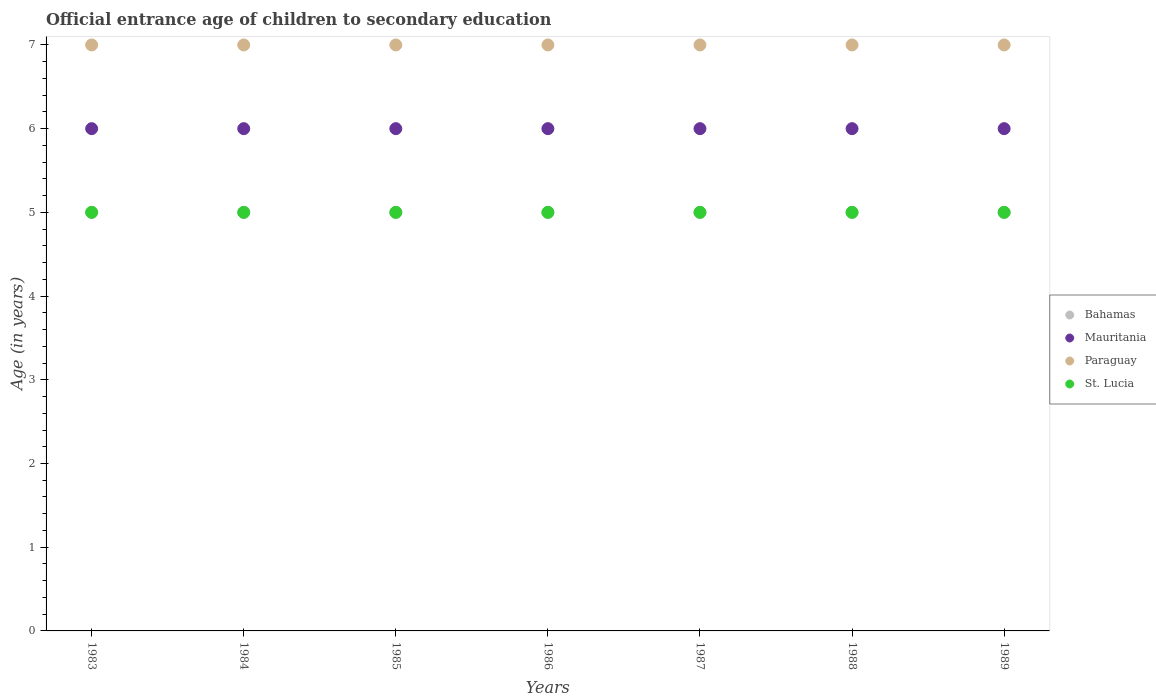How many different coloured dotlines are there?
Your answer should be compact. 4. What is the secondary school starting age of children in Mauritania in 1988?
Give a very brief answer. 6. Across all years, what is the maximum secondary school starting age of children in St. Lucia?
Offer a very short reply. 5. Across all years, what is the minimum secondary school starting age of children in St. Lucia?
Offer a terse response. 5. In which year was the secondary school starting age of children in St. Lucia minimum?
Your answer should be compact. 1983. What is the total secondary school starting age of children in Mauritania in the graph?
Give a very brief answer. 42. What is the difference between the secondary school starting age of children in Bahamas in 1986 and the secondary school starting age of children in Paraguay in 1987?
Provide a short and direct response. -2. In the year 1983, what is the difference between the secondary school starting age of children in St. Lucia and secondary school starting age of children in Mauritania?
Offer a very short reply. -1. Is the difference between the secondary school starting age of children in St. Lucia in 1988 and 1989 greater than the difference between the secondary school starting age of children in Mauritania in 1988 and 1989?
Your answer should be compact. No. What is the difference between the highest and the lowest secondary school starting age of children in Bahamas?
Your answer should be compact. 0. Is the secondary school starting age of children in Mauritania strictly less than the secondary school starting age of children in Paraguay over the years?
Provide a succinct answer. Yes. How many dotlines are there?
Offer a very short reply. 4. How many years are there in the graph?
Ensure brevity in your answer.  7. Are the values on the major ticks of Y-axis written in scientific E-notation?
Offer a terse response. No. Where does the legend appear in the graph?
Make the answer very short. Center right. How are the legend labels stacked?
Ensure brevity in your answer.  Vertical. What is the title of the graph?
Give a very brief answer. Official entrance age of children to secondary education. What is the label or title of the Y-axis?
Offer a very short reply. Age (in years). What is the Age (in years) of Mauritania in 1983?
Your answer should be very brief. 6. What is the Age (in years) in Bahamas in 1984?
Make the answer very short. 5. What is the Age (in years) in Paraguay in 1984?
Offer a terse response. 7. What is the Age (in years) in Paraguay in 1985?
Keep it short and to the point. 7. What is the Age (in years) in Mauritania in 1986?
Offer a very short reply. 6. What is the Age (in years) in Paraguay in 1986?
Give a very brief answer. 7. What is the Age (in years) in Bahamas in 1987?
Give a very brief answer. 5. What is the Age (in years) of Mauritania in 1988?
Offer a very short reply. 6. What is the Age (in years) in Paraguay in 1988?
Your answer should be compact. 7. What is the Age (in years) of St. Lucia in 1988?
Provide a succinct answer. 5. What is the Age (in years) of Bahamas in 1989?
Your answer should be compact. 5. What is the Age (in years) of Paraguay in 1989?
Ensure brevity in your answer.  7. Across all years, what is the maximum Age (in years) of Bahamas?
Offer a very short reply. 5. Across all years, what is the maximum Age (in years) of Mauritania?
Your answer should be compact. 6. Across all years, what is the maximum Age (in years) of Paraguay?
Provide a succinct answer. 7. Across all years, what is the minimum Age (in years) in Paraguay?
Make the answer very short. 7. Across all years, what is the minimum Age (in years) in St. Lucia?
Offer a terse response. 5. What is the total Age (in years) in St. Lucia in the graph?
Your answer should be very brief. 35. What is the difference between the Age (in years) of Mauritania in 1983 and that in 1984?
Your answer should be very brief. 0. What is the difference between the Age (in years) in Mauritania in 1983 and that in 1985?
Make the answer very short. 0. What is the difference between the Age (in years) of Paraguay in 1983 and that in 1985?
Provide a short and direct response. 0. What is the difference between the Age (in years) in Bahamas in 1983 and that in 1986?
Provide a succinct answer. 0. What is the difference between the Age (in years) of Paraguay in 1983 and that in 1986?
Keep it short and to the point. 0. What is the difference between the Age (in years) in Bahamas in 1983 and that in 1987?
Your response must be concise. 0. What is the difference between the Age (in years) of Paraguay in 1983 and that in 1987?
Your response must be concise. 0. What is the difference between the Age (in years) in St. Lucia in 1983 and that in 1987?
Offer a very short reply. 0. What is the difference between the Age (in years) of Mauritania in 1983 and that in 1988?
Your answer should be very brief. 0. What is the difference between the Age (in years) of Bahamas in 1983 and that in 1989?
Provide a succinct answer. 0. What is the difference between the Age (in years) in Mauritania in 1984 and that in 1985?
Offer a terse response. 0. What is the difference between the Age (in years) in Mauritania in 1984 and that in 1986?
Your answer should be compact. 0. What is the difference between the Age (in years) in Paraguay in 1984 and that in 1986?
Make the answer very short. 0. What is the difference between the Age (in years) of Bahamas in 1984 and that in 1987?
Your response must be concise. 0. What is the difference between the Age (in years) of Paraguay in 1984 and that in 1987?
Keep it short and to the point. 0. What is the difference between the Age (in years) of Bahamas in 1984 and that in 1988?
Keep it short and to the point. 0. What is the difference between the Age (in years) of Bahamas in 1984 and that in 1989?
Give a very brief answer. 0. What is the difference between the Age (in years) in Mauritania in 1984 and that in 1989?
Offer a terse response. 0. What is the difference between the Age (in years) of Paraguay in 1984 and that in 1989?
Keep it short and to the point. 0. What is the difference between the Age (in years) of St. Lucia in 1984 and that in 1989?
Provide a short and direct response. 0. What is the difference between the Age (in years) of Bahamas in 1985 and that in 1986?
Ensure brevity in your answer.  0. What is the difference between the Age (in years) in Paraguay in 1985 and that in 1986?
Your response must be concise. 0. What is the difference between the Age (in years) of St. Lucia in 1985 and that in 1986?
Offer a very short reply. 0. What is the difference between the Age (in years) in Bahamas in 1985 and that in 1987?
Provide a short and direct response. 0. What is the difference between the Age (in years) of Mauritania in 1985 and that in 1987?
Provide a succinct answer. 0. What is the difference between the Age (in years) of Mauritania in 1985 and that in 1988?
Ensure brevity in your answer.  0. What is the difference between the Age (in years) in St. Lucia in 1985 and that in 1989?
Provide a short and direct response. 0. What is the difference between the Age (in years) in Bahamas in 1986 and that in 1987?
Provide a succinct answer. 0. What is the difference between the Age (in years) of Mauritania in 1986 and that in 1987?
Make the answer very short. 0. What is the difference between the Age (in years) in Paraguay in 1986 and that in 1987?
Provide a succinct answer. 0. What is the difference between the Age (in years) in Paraguay in 1986 and that in 1988?
Your answer should be compact. 0. What is the difference between the Age (in years) of St. Lucia in 1986 and that in 1988?
Make the answer very short. 0. What is the difference between the Age (in years) of Paraguay in 1986 and that in 1989?
Give a very brief answer. 0. What is the difference between the Age (in years) in St. Lucia in 1986 and that in 1989?
Your answer should be very brief. 0. What is the difference between the Age (in years) of Bahamas in 1987 and that in 1988?
Your answer should be compact. 0. What is the difference between the Age (in years) of St. Lucia in 1987 and that in 1988?
Your answer should be compact. 0. What is the difference between the Age (in years) in Bahamas in 1987 and that in 1989?
Make the answer very short. 0. What is the difference between the Age (in years) of Mauritania in 1987 and that in 1989?
Ensure brevity in your answer.  0. What is the difference between the Age (in years) in St. Lucia in 1987 and that in 1989?
Your answer should be compact. 0. What is the difference between the Age (in years) of Bahamas in 1988 and that in 1989?
Your answer should be compact. 0. What is the difference between the Age (in years) of Paraguay in 1988 and that in 1989?
Offer a terse response. 0. What is the difference between the Age (in years) in Bahamas in 1983 and the Age (in years) in St. Lucia in 1984?
Your answer should be very brief. 0. What is the difference between the Age (in years) in Bahamas in 1983 and the Age (in years) in St. Lucia in 1986?
Make the answer very short. 0. What is the difference between the Age (in years) of Paraguay in 1983 and the Age (in years) of St. Lucia in 1986?
Give a very brief answer. 2. What is the difference between the Age (in years) of Bahamas in 1983 and the Age (in years) of Mauritania in 1987?
Give a very brief answer. -1. What is the difference between the Age (in years) in Bahamas in 1983 and the Age (in years) in St. Lucia in 1988?
Your answer should be very brief. 0. What is the difference between the Age (in years) in Mauritania in 1983 and the Age (in years) in Paraguay in 1988?
Offer a very short reply. -1. What is the difference between the Age (in years) of Paraguay in 1983 and the Age (in years) of St. Lucia in 1988?
Ensure brevity in your answer.  2. What is the difference between the Age (in years) in Bahamas in 1983 and the Age (in years) in Mauritania in 1989?
Provide a succinct answer. -1. What is the difference between the Age (in years) in Bahamas in 1983 and the Age (in years) in St. Lucia in 1989?
Keep it short and to the point. 0. What is the difference between the Age (in years) in Mauritania in 1983 and the Age (in years) in Paraguay in 1989?
Make the answer very short. -1. What is the difference between the Age (in years) in Mauritania in 1983 and the Age (in years) in St. Lucia in 1989?
Provide a short and direct response. 1. What is the difference between the Age (in years) in Bahamas in 1984 and the Age (in years) in Paraguay in 1985?
Keep it short and to the point. -2. What is the difference between the Age (in years) in Bahamas in 1984 and the Age (in years) in St. Lucia in 1985?
Your response must be concise. 0. What is the difference between the Age (in years) in Mauritania in 1984 and the Age (in years) in Paraguay in 1985?
Your answer should be very brief. -1. What is the difference between the Age (in years) in Mauritania in 1984 and the Age (in years) in St. Lucia in 1985?
Your answer should be very brief. 1. What is the difference between the Age (in years) in Bahamas in 1984 and the Age (in years) in Mauritania in 1986?
Your response must be concise. -1. What is the difference between the Age (in years) of Paraguay in 1984 and the Age (in years) of St. Lucia in 1986?
Offer a terse response. 2. What is the difference between the Age (in years) of Bahamas in 1984 and the Age (in years) of Mauritania in 1987?
Your answer should be compact. -1. What is the difference between the Age (in years) in Mauritania in 1984 and the Age (in years) in Paraguay in 1987?
Keep it short and to the point. -1. What is the difference between the Age (in years) in Mauritania in 1984 and the Age (in years) in St. Lucia in 1987?
Your answer should be very brief. 1. What is the difference between the Age (in years) in Paraguay in 1984 and the Age (in years) in St. Lucia in 1987?
Your answer should be very brief. 2. What is the difference between the Age (in years) in Mauritania in 1984 and the Age (in years) in Paraguay in 1988?
Your response must be concise. -1. What is the difference between the Age (in years) in Mauritania in 1984 and the Age (in years) in Paraguay in 1989?
Ensure brevity in your answer.  -1. What is the difference between the Age (in years) of Mauritania in 1984 and the Age (in years) of St. Lucia in 1989?
Provide a short and direct response. 1. What is the difference between the Age (in years) in Paraguay in 1984 and the Age (in years) in St. Lucia in 1989?
Keep it short and to the point. 2. What is the difference between the Age (in years) of Bahamas in 1985 and the Age (in years) of Mauritania in 1986?
Ensure brevity in your answer.  -1. What is the difference between the Age (in years) of Paraguay in 1985 and the Age (in years) of St. Lucia in 1986?
Give a very brief answer. 2. What is the difference between the Age (in years) in Bahamas in 1985 and the Age (in years) in Mauritania in 1987?
Offer a terse response. -1. What is the difference between the Age (in years) of Bahamas in 1985 and the Age (in years) of Paraguay in 1987?
Your answer should be compact. -2. What is the difference between the Age (in years) of Bahamas in 1985 and the Age (in years) of Paraguay in 1988?
Make the answer very short. -2. What is the difference between the Age (in years) in Bahamas in 1985 and the Age (in years) in St. Lucia in 1988?
Give a very brief answer. 0. What is the difference between the Age (in years) in Mauritania in 1985 and the Age (in years) in St. Lucia in 1988?
Make the answer very short. 1. What is the difference between the Age (in years) in Bahamas in 1985 and the Age (in years) in Mauritania in 1989?
Your answer should be very brief. -1. What is the difference between the Age (in years) in Bahamas in 1985 and the Age (in years) in Paraguay in 1989?
Offer a terse response. -2. What is the difference between the Age (in years) in Paraguay in 1985 and the Age (in years) in St. Lucia in 1989?
Offer a very short reply. 2. What is the difference between the Age (in years) in Bahamas in 1986 and the Age (in years) in Paraguay in 1987?
Keep it short and to the point. -2. What is the difference between the Age (in years) in Mauritania in 1986 and the Age (in years) in Paraguay in 1988?
Ensure brevity in your answer.  -1. What is the difference between the Age (in years) in Paraguay in 1986 and the Age (in years) in St. Lucia in 1988?
Ensure brevity in your answer.  2. What is the difference between the Age (in years) of Bahamas in 1986 and the Age (in years) of Mauritania in 1989?
Your response must be concise. -1. What is the difference between the Age (in years) in Bahamas in 1986 and the Age (in years) in Paraguay in 1989?
Offer a very short reply. -2. What is the difference between the Age (in years) of Bahamas in 1986 and the Age (in years) of St. Lucia in 1989?
Provide a short and direct response. 0. What is the difference between the Age (in years) in Mauritania in 1986 and the Age (in years) in St. Lucia in 1989?
Provide a short and direct response. 1. What is the difference between the Age (in years) in Mauritania in 1987 and the Age (in years) in Paraguay in 1988?
Keep it short and to the point. -1. What is the difference between the Age (in years) of Mauritania in 1987 and the Age (in years) of St. Lucia in 1988?
Make the answer very short. 1. What is the difference between the Age (in years) in Paraguay in 1987 and the Age (in years) in St. Lucia in 1988?
Offer a terse response. 2. What is the difference between the Age (in years) in Mauritania in 1987 and the Age (in years) in St. Lucia in 1989?
Make the answer very short. 1. What is the difference between the Age (in years) of Bahamas in 1988 and the Age (in years) of Mauritania in 1989?
Your answer should be compact. -1. What is the difference between the Age (in years) in Bahamas in 1988 and the Age (in years) in Paraguay in 1989?
Ensure brevity in your answer.  -2. What is the difference between the Age (in years) in Bahamas in 1988 and the Age (in years) in St. Lucia in 1989?
Provide a short and direct response. 0. What is the difference between the Age (in years) of Mauritania in 1988 and the Age (in years) of Paraguay in 1989?
Offer a very short reply. -1. What is the average Age (in years) of Bahamas per year?
Provide a succinct answer. 5. What is the average Age (in years) in Paraguay per year?
Keep it short and to the point. 7. In the year 1983, what is the difference between the Age (in years) in Bahamas and Age (in years) in Paraguay?
Make the answer very short. -2. In the year 1983, what is the difference between the Age (in years) in Paraguay and Age (in years) in St. Lucia?
Your answer should be compact. 2. In the year 1984, what is the difference between the Age (in years) in Bahamas and Age (in years) in St. Lucia?
Offer a very short reply. 0. In the year 1984, what is the difference between the Age (in years) of Mauritania and Age (in years) of Paraguay?
Give a very brief answer. -1. In the year 1985, what is the difference between the Age (in years) of Bahamas and Age (in years) of Mauritania?
Offer a terse response. -1. In the year 1985, what is the difference between the Age (in years) in Bahamas and Age (in years) in Paraguay?
Your answer should be compact. -2. In the year 1985, what is the difference between the Age (in years) of Bahamas and Age (in years) of St. Lucia?
Provide a short and direct response. 0. In the year 1985, what is the difference between the Age (in years) in Mauritania and Age (in years) in Paraguay?
Ensure brevity in your answer.  -1. In the year 1985, what is the difference between the Age (in years) of Mauritania and Age (in years) of St. Lucia?
Give a very brief answer. 1. In the year 1985, what is the difference between the Age (in years) in Paraguay and Age (in years) in St. Lucia?
Your response must be concise. 2. In the year 1986, what is the difference between the Age (in years) of Bahamas and Age (in years) of Mauritania?
Your response must be concise. -1. In the year 1986, what is the difference between the Age (in years) in Mauritania and Age (in years) in Paraguay?
Your response must be concise. -1. In the year 1986, what is the difference between the Age (in years) in Mauritania and Age (in years) in St. Lucia?
Keep it short and to the point. 1. In the year 1986, what is the difference between the Age (in years) in Paraguay and Age (in years) in St. Lucia?
Keep it short and to the point. 2. In the year 1987, what is the difference between the Age (in years) in Bahamas and Age (in years) in Mauritania?
Offer a terse response. -1. In the year 1987, what is the difference between the Age (in years) in Bahamas and Age (in years) in Paraguay?
Provide a succinct answer. -2. In the year 1987, what is the difference between the Age (in years) in Mauritania and Age (in years) in Paraguay?
Offer a very short reply. -1. In the year 1987, what is the difference between the Age (in years) in Mauritania and Age (in years) in St. Lucia?
Keep it short and to the point. 1. In the year 1987, what is the difference between the Age (in years) in Paraguay and Age (in years) in St. Lucia?
Give a very brief answer. 2. In the year 1988, what is the difference between the Age (in years) of Mauritania and Age (in years) of St. Lucia?
Your answer should be very brief. 1. In the year 1988, what is the difference between the Age (in years) in Paraguay and Age (in years) in St. Lucia?
Make the answer very short. 2. In the year 1989, what is the difference between the Age (in years) of Bahamas and Age (in years) of Mauritania?
Keep it short and to the point. -1. In the year 1989, what is the difference between the Age (in years) of Mauritania and Age (in years) of Paraguay?
Provide a succinct answer. -1. What is the ratio of the Age (in years) of Mauritania in 1983 to that in 1984?
Provide a succinct answer. 1. What is the ratio of the Age (in years) of Mauritania in 1983 to that in 1985?
Give a very brief answer. 1. What is the ratio of the Age (in years) of Paraguay in 1983 to that in 1985?
Ensure brevity in your answer.  1. What is the ratio of the Age (in years) of St. Lucia in 1983 to that in 1985?
Your response must be concise. 1. What is the ratio of the Age (in years) in Bahamas in 1983 to that in 1986?
Give a very brief answer. 1. What is the ratio of the Age (in years) of Mauritania in 1983 to that in 1986?
Provide a short and direct response. 1. What is the ratio of the Age (in years) of Paraguay in 1983 to that in 1986?
Provide a succinct answer. 1. What is the ratio of the Age (in years) of St. Lucia in 1983 to that in 1986?
Ensure brevity in your answer.  1. What is the ratio of the Age (in years) of Bahamas in 1983 to that in 1987?
Provide a short and direct response. 1. What is the ratio of the Age (in years) in Mauritania in 1983 to that in 1987?
Provide a succinct answer. 1. What is the ratio of the Age (in years) of St. Lucia in 1983 to that in 1987?
Your answer should be very brief. 1. What is the ratio of the Age (in years) of Bahamas in 1983 to that in 1988?
Ensure brevity in your answer.  1. What is the ratio of the Age (in years) in Paraguay in 1983 to that in 1988?
Give a very brief answer. 1. What is the ratio of the Age (in years) in St. Lucia in 1983 to that in 1988?
Provide a short and direct response. 1. What is the ratio of the Age (in years) in Bahamas in 1983 to that in 1989?
Make the answer very short. 1. What is the ratio of the Age (in years) of Mauritania in 1983 to that in 1989?
Your answer should be very brief. 1. What is the ratio of the Age (in years) in St. Lucia in 1983 to that in 1989?
Make the answer very short. 1. What is the ratio of the Age (in years) in Bahamas in 1984 to that in 1985?
Your answer should be compact. 1. What is the ratio of the Age (in years) in Mauritania in 1984 to that in 1985?
Keep it short and to the point. 1. What is the ratio of the Age (in years) of Paraguay in 1984 to that in 1985?
Keep it short and to the point. 1. What is the ratio of the Age (in years) in Bahamas in 1984 to that in 1986?
Your answer should be compact. 1. What is the ratio of the Age (in years) of Mauritania in 1984 to that in 1986?
Offer a terse response. 1. What is the ratio of the Age (in years) in Paraguay in 1984 to that in 1986?
Keep it short and to the point. 1. What is the ratio of the Age (in years) in St. Lucia in 1984 to that in 1986?
Give a very brief answer. 1. What is the ratio of the Age (in years) in Bahamas in 1984 to that in 1987?
Give a very brief answer. 1. What is the ratio of the Age (in years) in Paraguay in 1984 to that in 1987?
Ensure brevity in your answer.  1. What is the ratio of the Age (in years) of St. Lucia in 1984 to that in 1987?
Give a very brief answer. 1. What is the ratio of the Age (in years) in Mauritania in 1984 to that in 1988?
Keep it short and to the point. 1. What is the ratio of the Age (in years) in St. Lucia in 1984 to that in 1988?
Your response must be concise. 1. What is the ratio of the Age (in years) in Bahamas in 1984 to that in 1989?
Provide a succinct answer. 1. What is the ratio of the Age (in years) in Mauritania in 1984 to that in 1989?
Provide a succinct answer. 1. What is the ratio of the Age (in years) in Bahamas in 1985 to that in 1986?
Your response must be concise. 1. What is the ratio of the Age (in years) of Mauritania in 1985 to that in 1986?
Provide a short and direct response. 1. What is the ratio of the Age (in years) of St. Lucia in 1985 to that in 1986?
Offer a very short reply. 1. What is the ratio of the Age (in years) of Mauritania in 1985 to that in 1987?
Offer a terse response. 1. What is the ratio of the Age (in years) in Paraguay in 1985 to that in 1988?
Offer a terse response. 1. What is the ratio of the Age (in years) of St. Lucia in 1985 to that in 1988?
Your answer should be compact. 1. What is the ratio of the Age (in years) in Mauritania in 1985 to that in 1989?
Make the answer very short. 1. What is the ratio of the Age (in years) in Mauritania in 1986 to that in 1987?
Give a very brief answer. 1. What is the ratio of the Age (in years) in St. Lucia in 1986 to that in 1987?
Offer a very short reply. 1. What is the ratio of the Age (in years) in Bahamas in 1986 to that in 1988?
Your answer should be compact. 1. What is the ratio of the Age (in years) in Mauritania in 1986 to that in 1988?
Offer a terse response. 1. What is the ratio of the Age (in years) in Paraguay in 1986 to that in 1988?
Give a very brief answer. 1. What is the ratio of the Age (in years) of Bahamas in 1986 to that in 1989?
Offer a terse response. 1. What is the ratio of the Age (in years) of Mauritania in 1986 to that in 1989?
Ensure brevity in your answer.  1. What is the ratio of the Age (in years) of St. Lucia in 1986 to that in 1989?
Offer a terse response. 1. What is the ratio of the Age (in years) in Mauritania in 1987 to that in 1988?
Your answer should be compact. 1. What is the ratio of the Age (in years) in Bahamas in 1987 to that in 1989?
Provide a succinct answer. 1. What is the ratio of the Age (in years) of Paraguay in 1987 to that in 1989?
Provide a succinct answer. 1. What is the ratio of the Age (in years) of Mauritania in 1988 to that in 1989?
Offer a terse response. 1. What is the ratio of the Age (in years) of Paraguay in 1988 to that in 1989?
Provide a succinct answer. 1. What is the ratio of the Age (in years) of St. Lucia in 1988 to that in 1989?
Provide a short and direct response. 1. What is the difference between the highest and the second highest Age (in years) in Paraguay?
Offer a very short reply. 0. What is the difference between the highest and the lowest Age (in years) in St. Lucia?
Give a very brief answer. 0. 